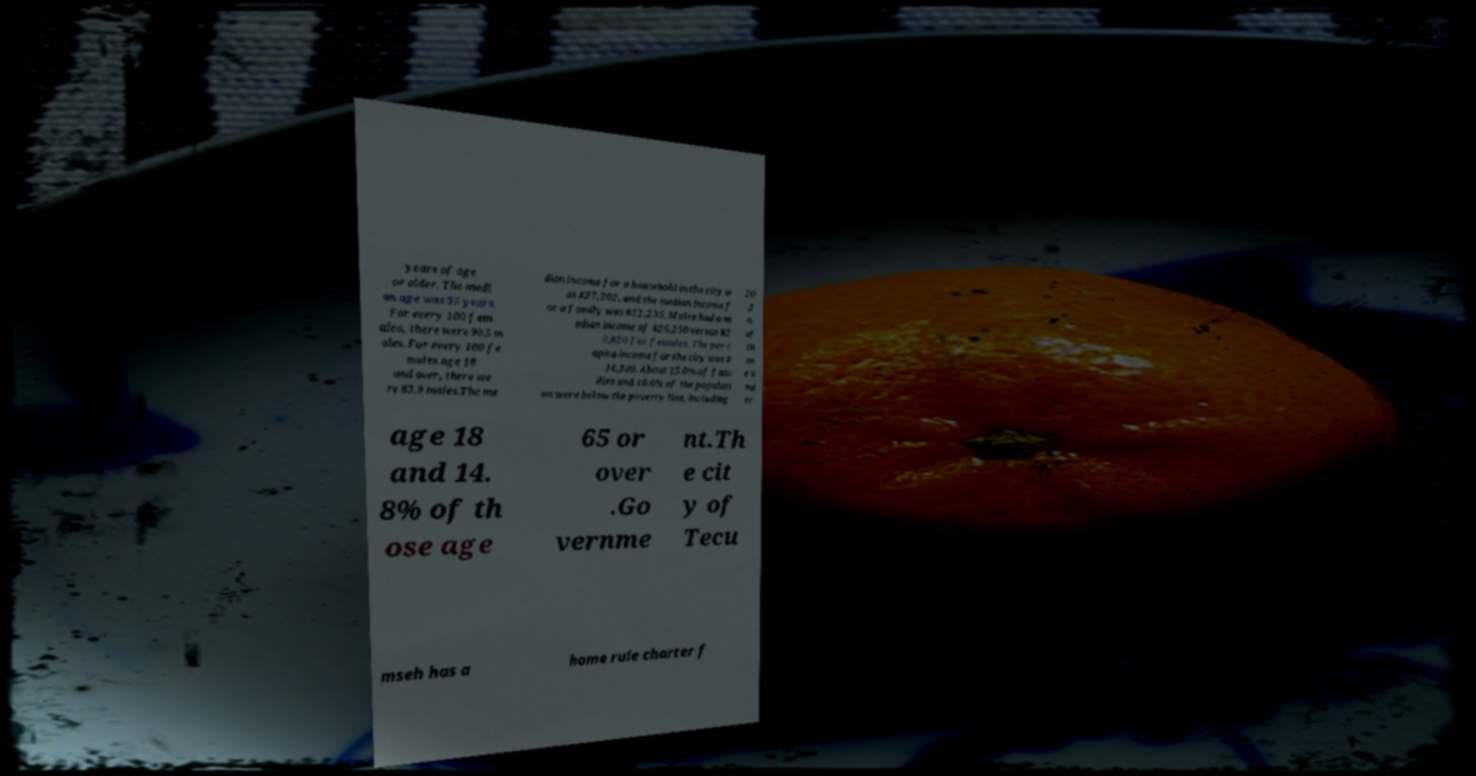Could you assist in decoding the text presented in this image and type it out clearly? years of age or older. The medi an age was 35 years. For every 100 fem ales, there were 90.5 m ales. For every 100 fe males age 18 and over, there we re 83.9 males.The me dian income for a household in the city w as $27,202, and the median income f or a family was $32,235. Males had a m edian income of $26,250 versus $2 0,820 for females. The per c apita income for the city was $ 14,300. About 15.0% of fam ilies and 16.6% of the populati on were below the poverty line, including 20 .3 % of th os e u nd er age 18 and 14. 8% of th ose age 65 or over .Go vernme nt.Th e cit y of Tecu mseh has a home rule charter f 